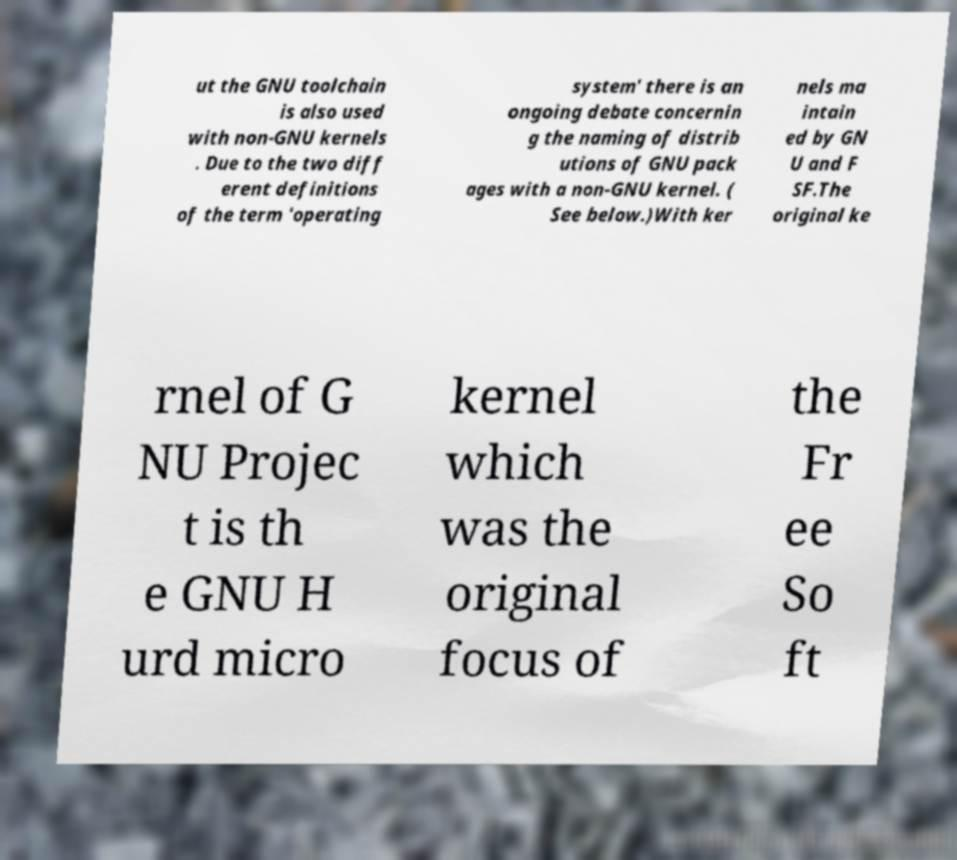Could you assist in decoding the text presented in this image and type it out clearly? ut the GNU toolchain is also used with non-GNU kernels . Due to the two diff erent definitions of the term 'operating system' there is an ongoing debate concernin g the naming of distrib utions of GNU pack ages with a non-GNU kernel. ( See below.)With ker nels ma intain ed by GN U and F SF.The original ke rnel of G NU Projec t is th e GNU H urd micro kernel which was the original focus of the Fr ee So ft 